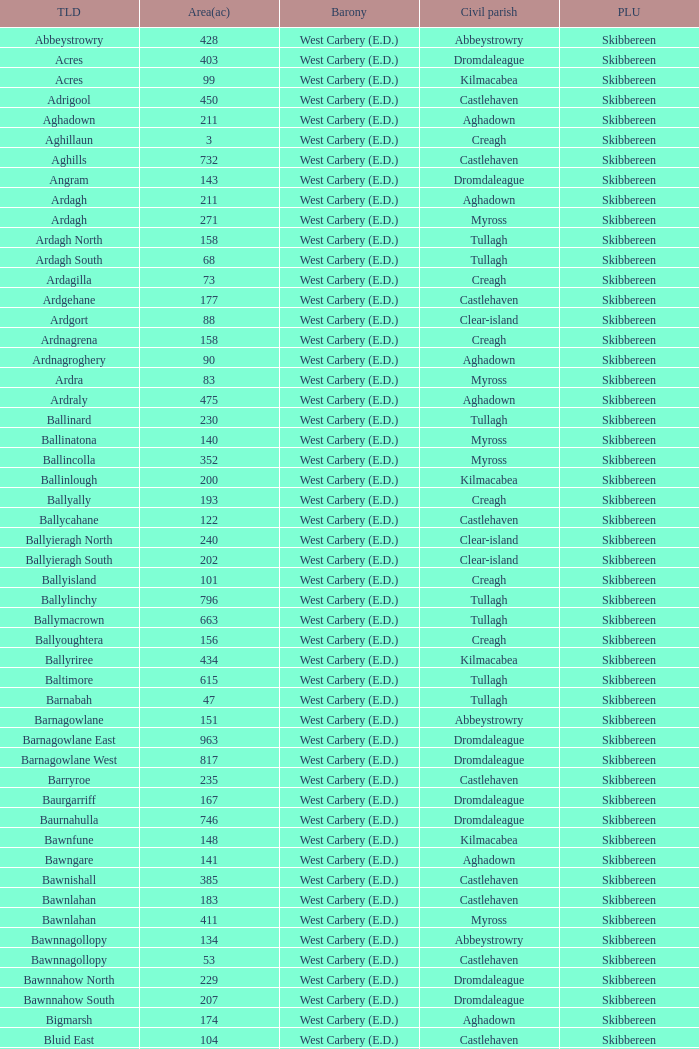What are the areas (in acres) of the Kilnahera East townland? 257.0. 